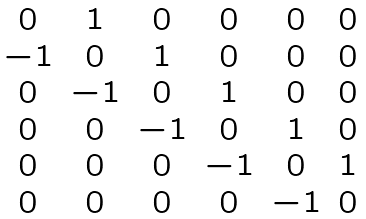Convert formula to latex. <formula><loc_0><loc_0><loc_500><loc_500>\begin{matrix} 0 & 1 & 0 & 0 & 0 & 0 \\ - 1 & 0 & 1 & 0 & 0 & 0 \\ 0 & - 1 & 0 & 1 & 0 & 0 \\ 0 & 0 & - 1 & 0 & 1 & 0 \\ 0 & 0 & 0 & - 1 & 0 & 1 \\ 0 & 0 & 0 & 0 & - 1 & 0 \\ \end{matrix}</formula> 